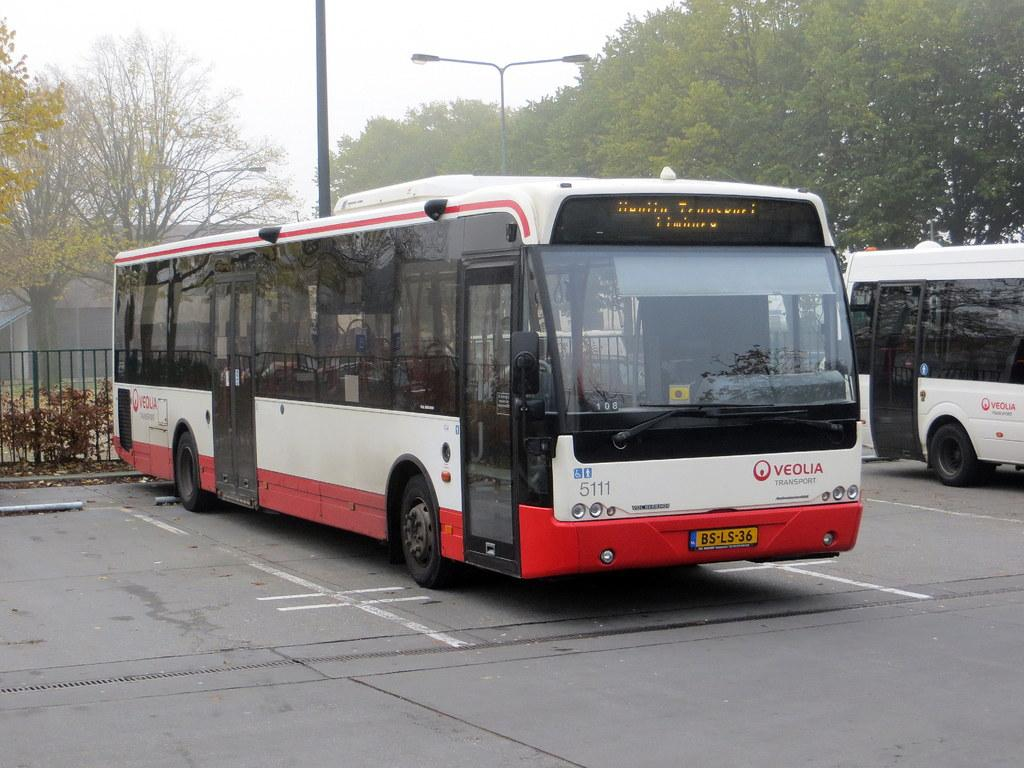<image>
Present a compact description of the photo's key features. A large bus from Veolia Transport is parked in a parking spot. 